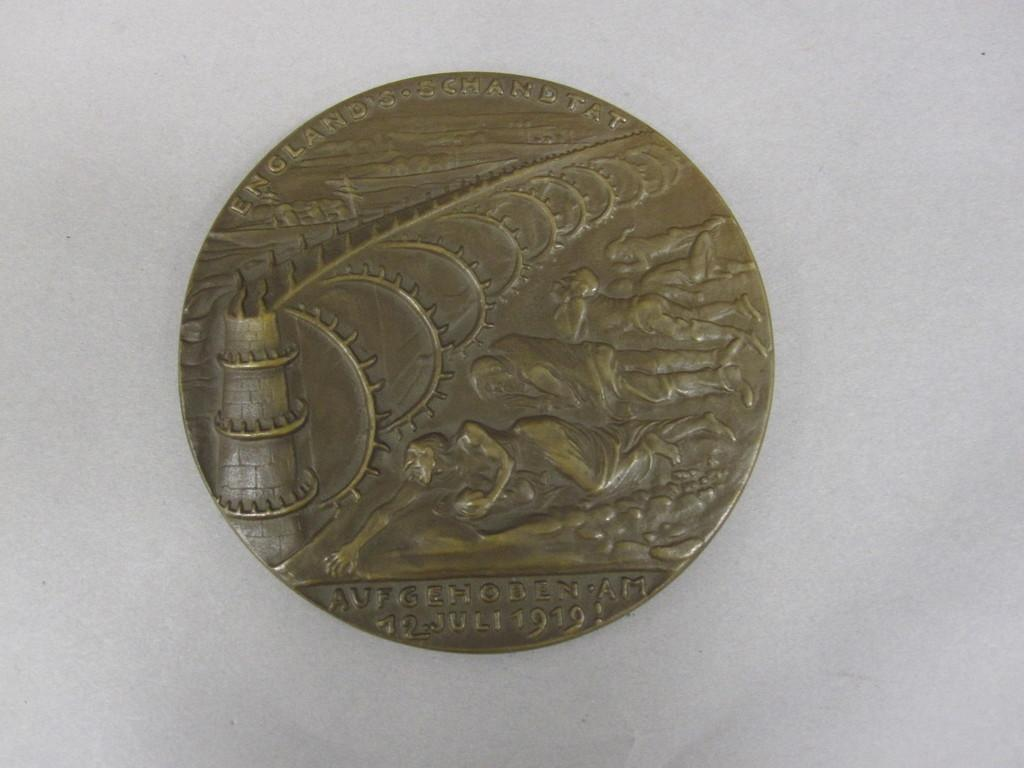Provide a one-sentence caption for the provided image. an old english metal coin minted in 1919. 